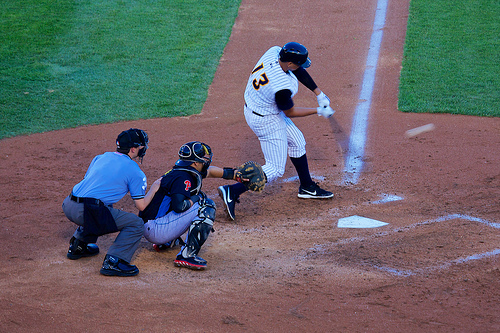How does the equipment worn by the catcher contribute to his role? The catcher's equipment, including the helmet, face mask, chest protector, and glove, is crucial for safety and effectiveness. It protects him from fast-moving balls and helps him catch pitches with precision, aiding his role in defending home plate against the batter. 